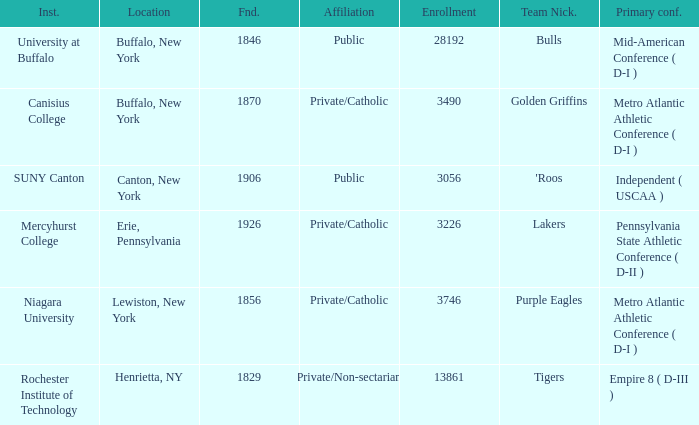What affiliation is Erie, Pennsylvania? Private/Catholic. 